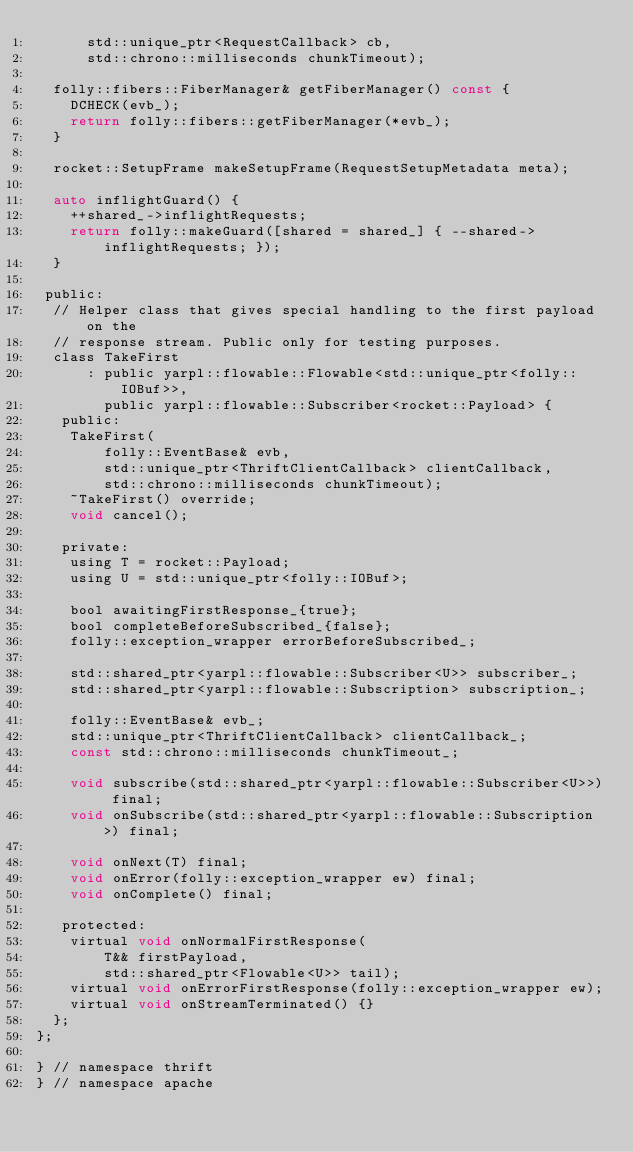Convert code to text. <code><loc_0><loc_0><loc_500><loc_500><_C_>      std::unique_ptr<RequestCallback> cb,
      std::chrono::milliseconds chunkTimeout);

  folly::fibers::FiberManager& getFiberManager() const {
    DCHECK(evb_);
    return folly::fibers::getFiberManager(*evb_);
  }

  rocket::SetupFrame makeSetupFrame(RequestSetupMetadata meta);

  auto inflightGuard() {
    ++shared_->inflightRequests;
    return folly::makeGuard([shared = shared_] { --shared->inflightRequests; });
  }

 public:
  // Helper class that gives special handling to the first payload on the
  // response stream. Public only for testing purposes.
  class TakeFirst
      : public yarpl::flowable::Flowable<std::unique_ptr<folly::IOBuf>>,
        public yarpl::flowable::Subscriber<rocket::Payload> {
   public:
    TakeFirst(
        folly::EventBase& evb,
        std::unique_ptr<ThriftClientCallback> clientCallback,
        std::chrono::milliseconds chunkTimeout);
    ~TakeFirst() override;
    void cancel();

   private:
    using T = rocket::Payload;
    using U = std::unique_ptr<folly::IOBuf>;

    bool awaitingFirstResponse_{true};
    bool completeBeforeSubscribed_{false};
    folly::exception_wrapper errorBeforeSubscribed_;

    std::shared_ptr<yarpl::flowable::Subscriber<U>> subscriber_;
    std::shared_ptr<yarpl::flowable::Subscription> subscription_;

    folly::EventBase& evb_;
    std::unique_ptr<ThriftClientCallback> clientCallback_;
    const std::chrono::milliseconds chunkTimeout_;

    void subscribe(std::shared_ptr<yarpl::flowable::Subscriber<U>>) final;
    void onSubscribe(std::shared_ptr<yarpl::flowable::Subscription>) final;

    void onNext(T) final;
    void onError(folly::exception_wrapper ew) final;
    void onComplete() final;

   protected:
    virtual void onNormalFirstResponse(
        T&& firstPayload,
        std::shared_ptr<Flowable<U>> tail);
    virtual void onErrorFirstResponse(folly::exception_wrapper ew);
    virtual void onStreamTerminated() {}
  };
};

} // namespace thrift
} // namespace apache
</code> 